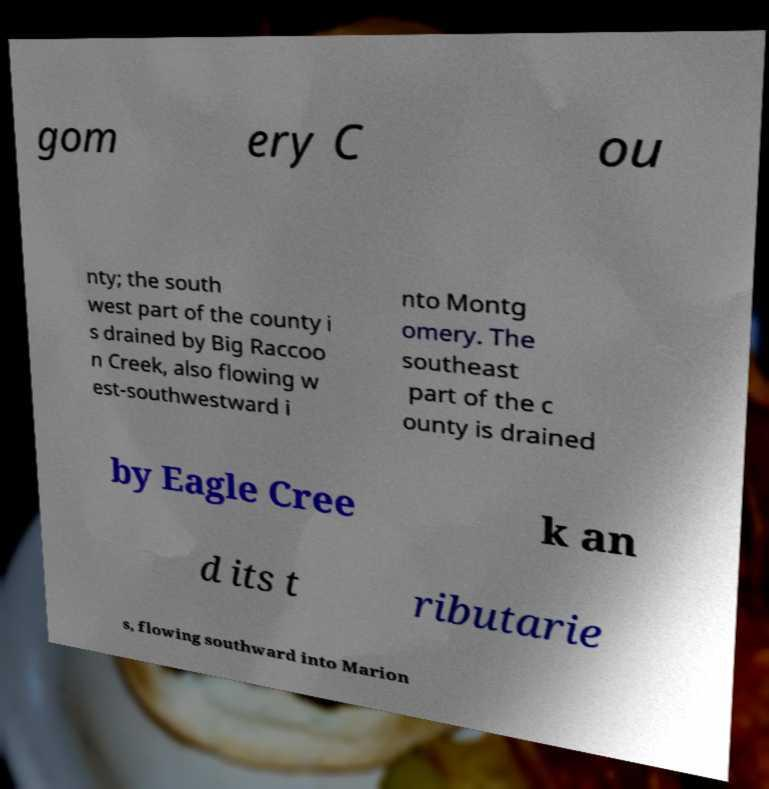Can you accurately transcribe the text from the provided image for me? gom ery C ou nty; the south west part of the county i s drained by Big Raccoo n Creek, also flowing w est-southwestward i nto Montg omery. The southeast part of the c ounty is drained by Eagle Cree k an d its t ributarie s, flowing southward into Marion 